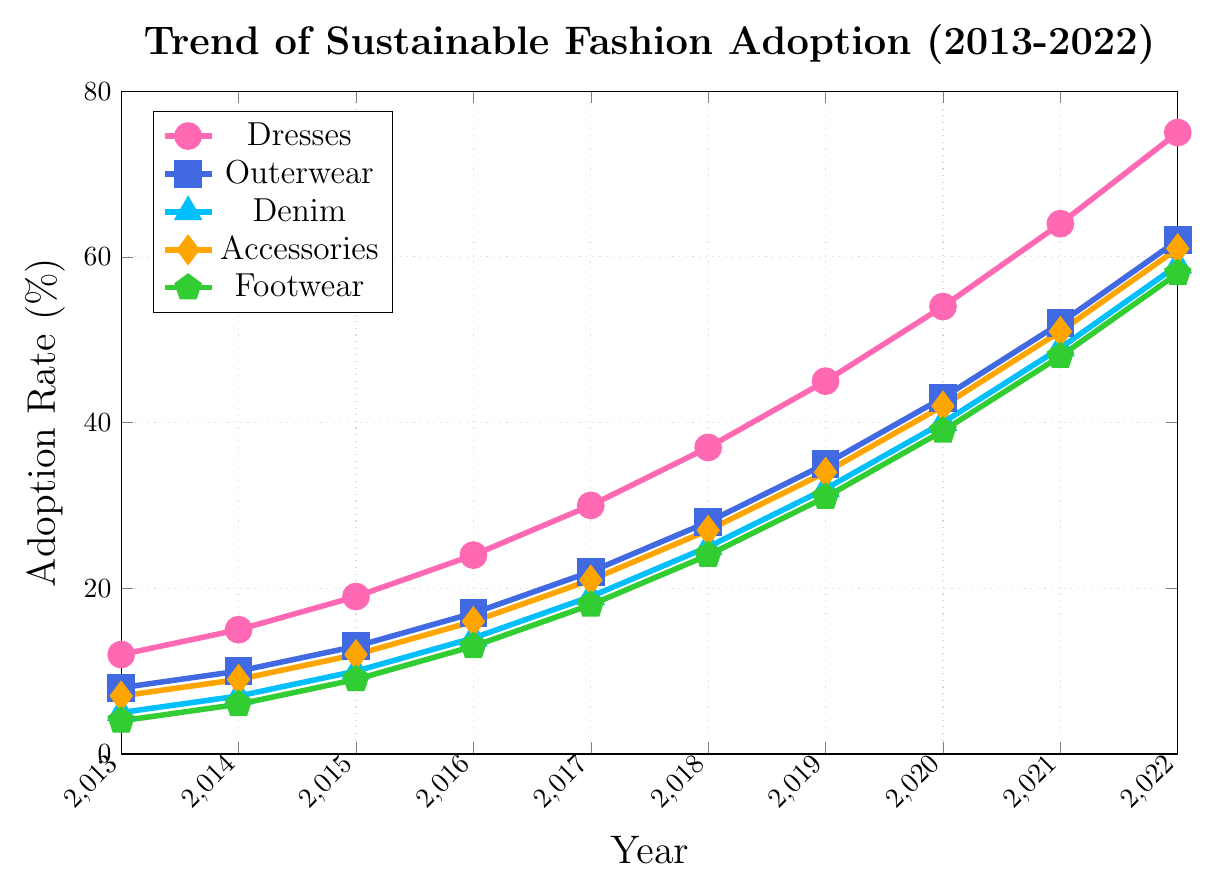When did the adoption rate for dresses first surpass 50%? Look at the line for dresses; the corresponding marker for dresses exceeds 50% in the year 2020.
Answer: 2020 Which clothing category had the highest adoption rate in the year 2019? For 2019, compare the adoption rates of all categories. Dresses have a 45% adoption rate, which is the highest among all categories.
Answer: Dresses How much did the adoption rate for footwear increase from 2015 to 2017? Check the adoption rate for footwear in 2015 (9%) and 2017 (18%). The increase is 18% - 9% = 9%.
Answer: 9% What is the average adoption rate for accessories over the period 2013-2016? The adoption rates for accessories are 7%, 9%, 12%, and 16% from 2013 to 2016. The average is (7+9+12+16)/4 = 11%.
Answer: 11% By how much did the adoption rate of denim lag behind outerwear in the year 2022? For 2022, look at denim (59%) and outerwear (62%). The lag is 62% - 59% = 3%.
Answer: 3% Which category experienced the largest absolute increase in adoption rate from 2017 to 2022? Calculate the increase for each category from 2017 to 2022: Dresses (75-30=45), Outerwear (62-22=40), Denim (59-19=40), Accessories (61-21=40), Footwear (58-18=40). Dresses experienced the largest absolute increase of 45%.
Answer: Dresses How does the adoption rate of outerwear in 2016 compare to the adoption rate of denim in 2018? Find the adoption rate of outerwear in 2016 (17%) and denim in 2018 (25%). Since 17% < 25%, denim has a higher adoption rate in 2018.
Answer: Denim in 2018 is higher What is the difference in adoption rates between dresses and accessories in 2021? In 2021, the adoption rate for dresses is 64% and for accessories is 51%. The difference is 64% - 51% = 13%.
Answer: 13% How did the adoption rate of dresses and outerwear change between 2013 and 2014? The adoption rate for dresses changed from 12% to 15% (an increase of 3%), while for outerwear, it changed from 8% to 10% (an increase of 2%).
Answer: Dresses increased by 3%, outerwear by 2% Which category had the smallest adoption rate in 2015? Compare the adoption rates in 2015: Footwear (9%), which is the smallest.
Answer: Footwear 